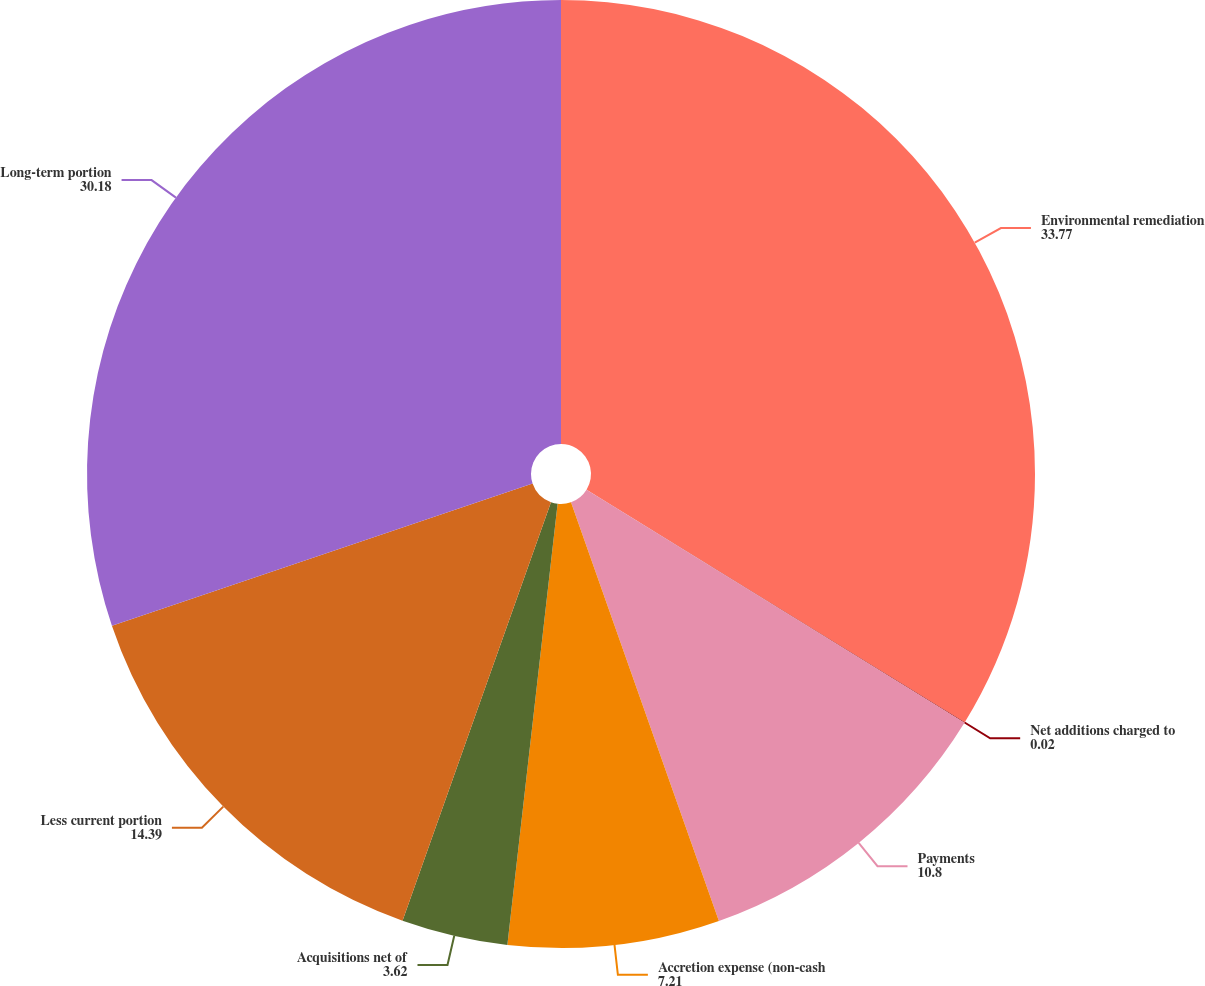<chart> <loc_0><loc_0><loc_500><loc_500><pie_chart><fcel>Environmental remediation<fcel>Net additions charged to<fcel>Payments<fcel>Accretion expense (non-cash<fcel>Acquisitions net of<fcel>Less current portion<fcel>Long-term portion<nl><fcel>33.77%<fcel>0.02%<fcel>10.8%<fcel>7.21%<fcel>3.62%<fcel>14.39%<fcel>30.18%<nl></chart> 